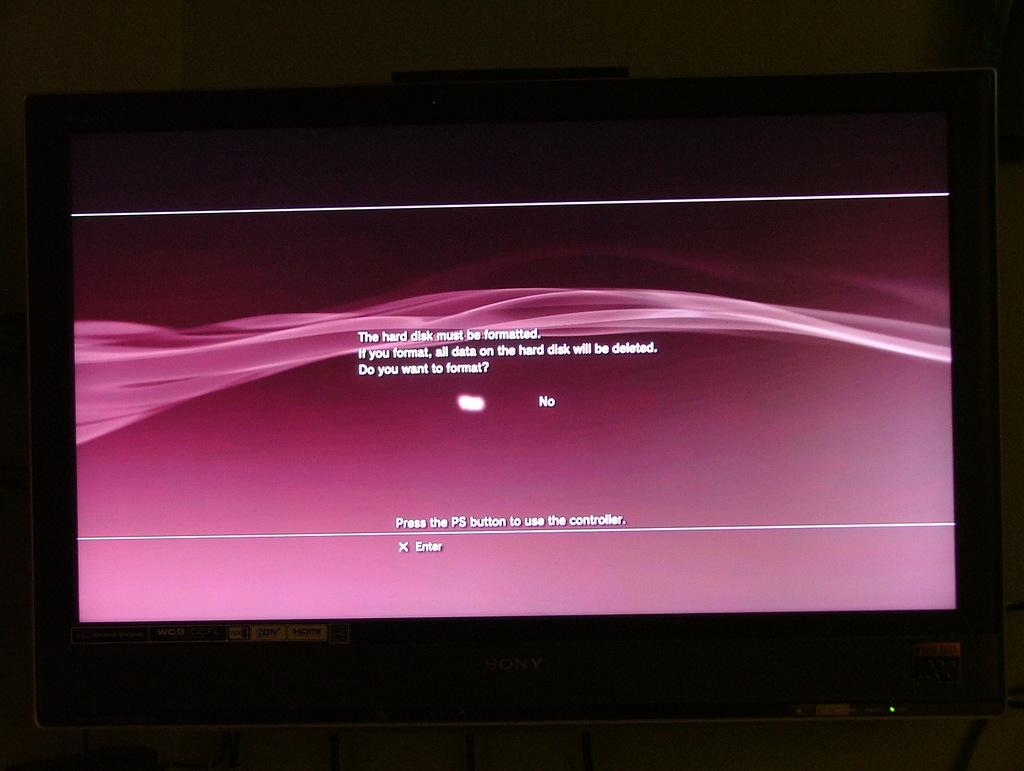<image>
Relay a brief, clear account of the picture shown. A message on a montior saying that the hard disk must be formatted. 